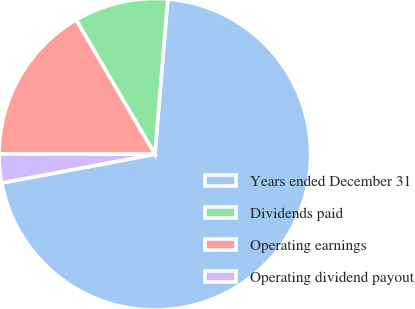Convert chart to OTSL. <chart><loc_0><loc_0><loc_500><loc_500><pie_chart><fcel>Years ended December 31<fcel>Dividends paid<fcel>Operating earnings<fcel>Operating dividend payout<nl><fcel>70.73%<fcel>9.76%<fcel>16.53%<fcel>2.98%<nl></chart> 